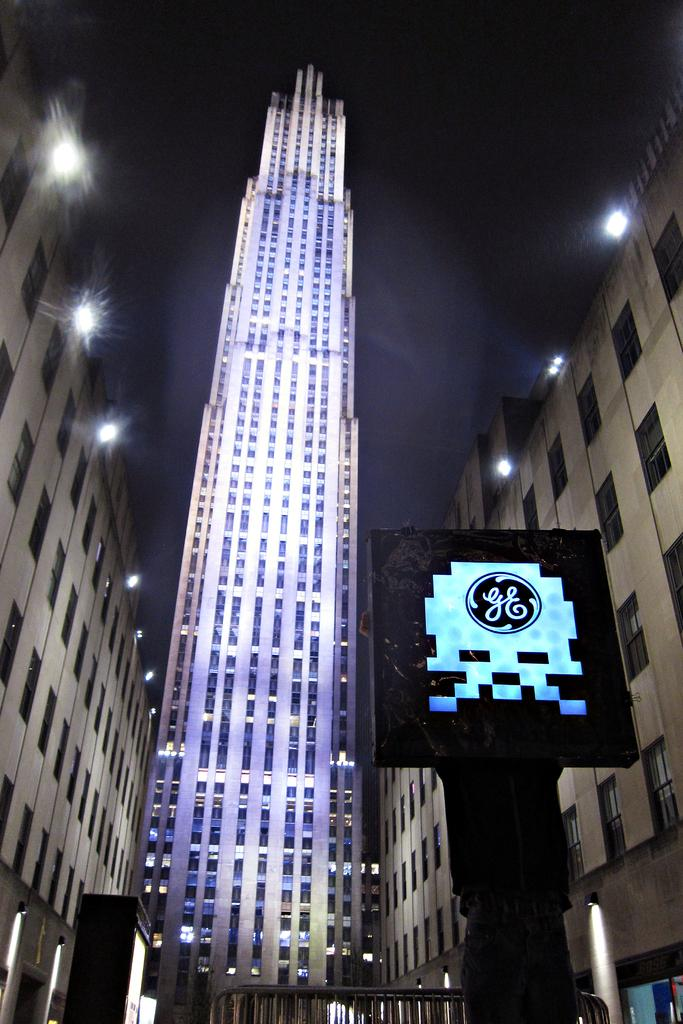What type of structures can be seen in the image? There are buildings in the image. What can be seen illuminating the scene in the image? There are lights in the image. What else is present in the image besides buildings and lights? There are objects in the image. Can you describe the person in the image? There is a person holding an object in the image. What is visible in the background of the image? The sky is visible in the image. What type of government is depicted in the image? There is no depiction of a government in the image. How many children are present in the image? There is no mention of children in the image. 